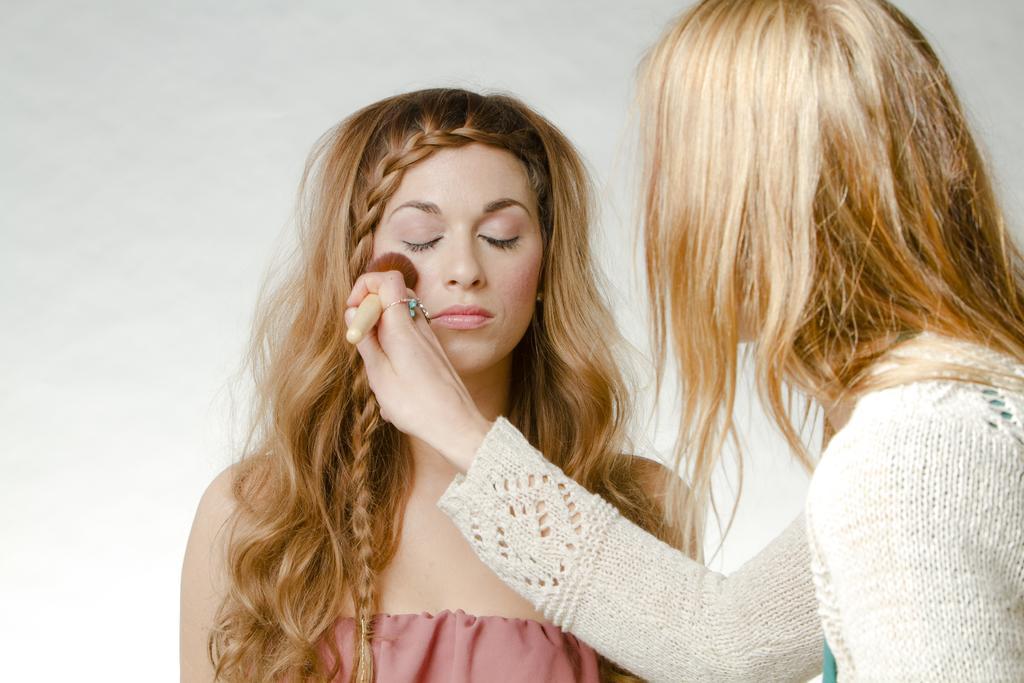Could you give a brief overview of what you see in this image? Here we can see two women and she is holding a brush with her hand. There is a white background. 